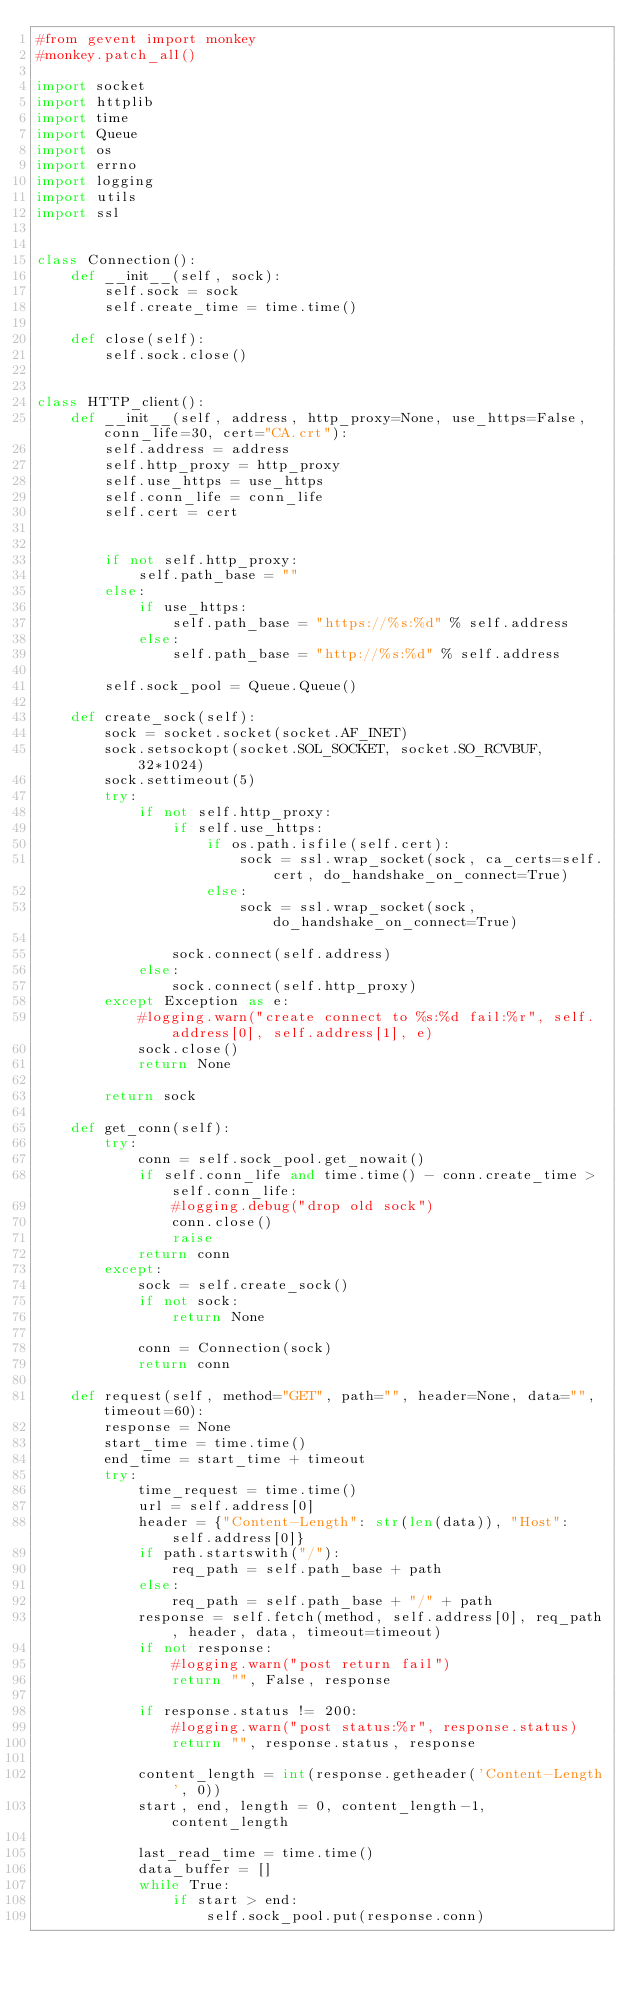<code> <loc_0><loc_0><loc_500><loc_500><_Python_>#from gevent import monkey
#monkey.patch_all()

import socket
import httplib
import time
import Queue
import os
import errno
import logging
import utils
import ssl


class Connection():
    def __init__(self, sock):
        self.sock = sock
        self.create_time = time.time()

    def close(self):
        self.sock.close()


class HTTP_client():
    def __init__(self, address, http_proxy=None, use_https=False, conn_life=30, cert="CA.crt"):
        self.address = address
        self.http_proxy = http_proxy
        self.use_https = use_https
        self.conn_life = conn_life
        self.cert = cert


        if not self.http_proxy:
            self.path_base = ""
        else:
            if use_https:
                self.path_base = "https://%s:%d" % self.address
            else:
                self.path_base = "http://%s:%d" % self.address

        self.sock_pool = Queue.Queue()

    def create_sock(self):
        sock = socket.socket(socket.AF_INET)
        sock.setsockopt(socket.SOL_SOCKET, socket.SO_RCVBUF, 32*1024)
        sock.settimeout(5)
        try:
            if not self.http_proxy:
                if self.use_https:
                    if os.path.isfile(self.cert):
                        sock = ssl.wrap_socket(sock, ca_certs=self.cert, do_handshake_on_connect=True)
                    else:
                        sock = ssl.wrap_socket(sock, do_handshake_on_connect=True)

                sock.connect(self.address)
            else:
                sock.connect(self.http_proxy)
        except Exception as e:
            #logging.warn("create connect to %s:%d fail:%r", self.address[0], self.address[1], e)
            sock.close()
            return None

        return sock

    def get_conn(self):
        try:
            conn = self.sock_pool.get_nowait()
            if self.conn_life and time.time() - conn.create_time > self.conn_life:
                #logging.debug("drop old sock")
                conn.close()
                raise
            return conn
        except:
            sock = self.create_sock()
            if not sock:
                return None

            conn = Connection(sock)
            return conn

    def request(self, method="GET", path="", header=None, data="", timeout=60):
        response = None
        start_time = time.time()
        end_time = start_time + timeout
        try:
            time_request = time.time()
            url = self.address[0]
            header = {"Content-Length": str(len(data)), "Host": self.address[0]}
            if path.startswith("/"):
                req_path = self.path_base + path
            else:
                req_path = self.path_base + "/" + path
            response = self.fetch(method, self.address[0], req_path, header, data, timeout=timeout)
            if not response:
                #logging.warn("post return fail")
                return "", False, response

            if response.status != 200:
                #logging.warn("post status:%r", response.status)
                return "", response.status, response

            content_length = int(response.getheader('Content-Length', 0))
            start, end, length = 0, content_length-1, content_length

            last_read_time = time.time()
            data_buffer = []
            while True:
                if start > end:
                    self.sock_pool.put(response.conn)</code> 